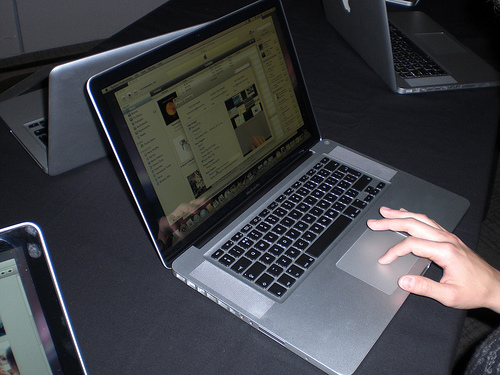<image>
Can you confirm if the laptop is behind the table? No. The laptop is not behind the table. From this viewpoint, the laptop appears to be positioned elsewhere in the scene. 